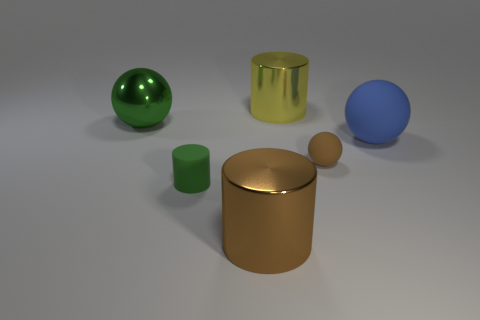There is a blue object that is the same shape as the large green object; what is its size?
Provide a short and direct response. Large. The matte object that is the same shape as the brown shiny object is what color?
Offer a very short reply. Green. What number of shiny spheres have the same color as the matte cylinder?
Ensure brevity in your answer.  1. Is the blue ball the same size as the brown cylinder?
Give a very brief answer. Yes. What is the tiny brown thing made of?
Give a very brief answer. Rubber. There is a small cylinder that is the same material as the large blue ball; what is its color?
Your answer should be compact. Green. Is the material of the blue thing the same as the thing that is behind the green shiny sphere?
Your answer should be compact. No. How many other large yellow things have the same material as the big yellow object?
Offer a terse response. 0. There is a big yellow object that is on the left side of the blue rubber object; what shape is it?
Your answer should be very brief. Cylinder. Is the ball that is left of the yellow cylinder made of the same material as the big cylinder in front of the big rubber thing?
Provide a succinct answer. Yes. 